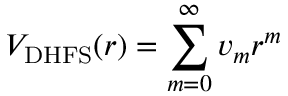Convert formula to latex. <formula><loc_0><loc_0><loc_500><loc_500>V _ { D H F S } ( r ) = \sum _ { m = 0 } ^ { \infty } v _ { m } r ^ { m }</formula> 